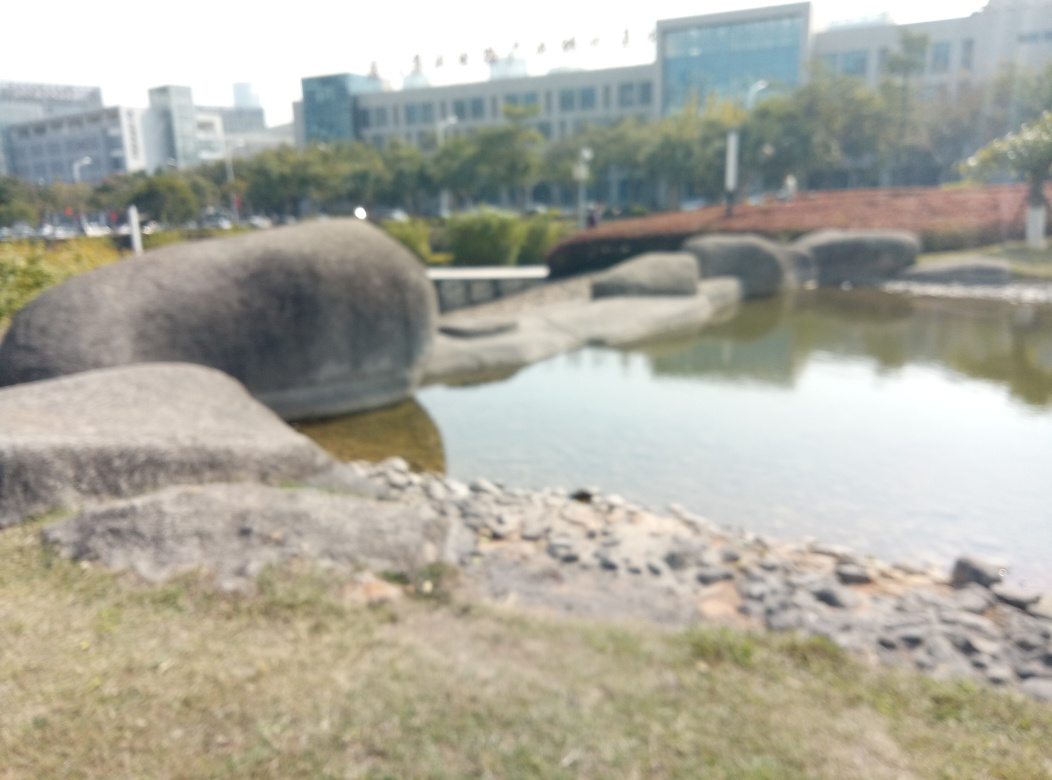What might be the function of these stone structures in the image? Although the image is blurry, the stone structures resemble parts of a landscaping feature, possibly serving as stepping stones or elements in a rock garden within a park or public space. Their design and placement suggest they were intended to harmonize with the natural environment around them. 